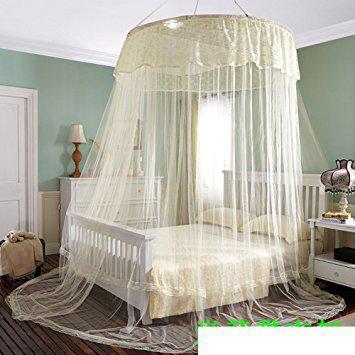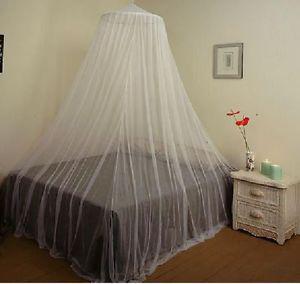The first image is the image on the left, the second image is the image on the right. Considering the images on both sides, is "There are two white round canopies." valid? Answer yes or no. Yes. 